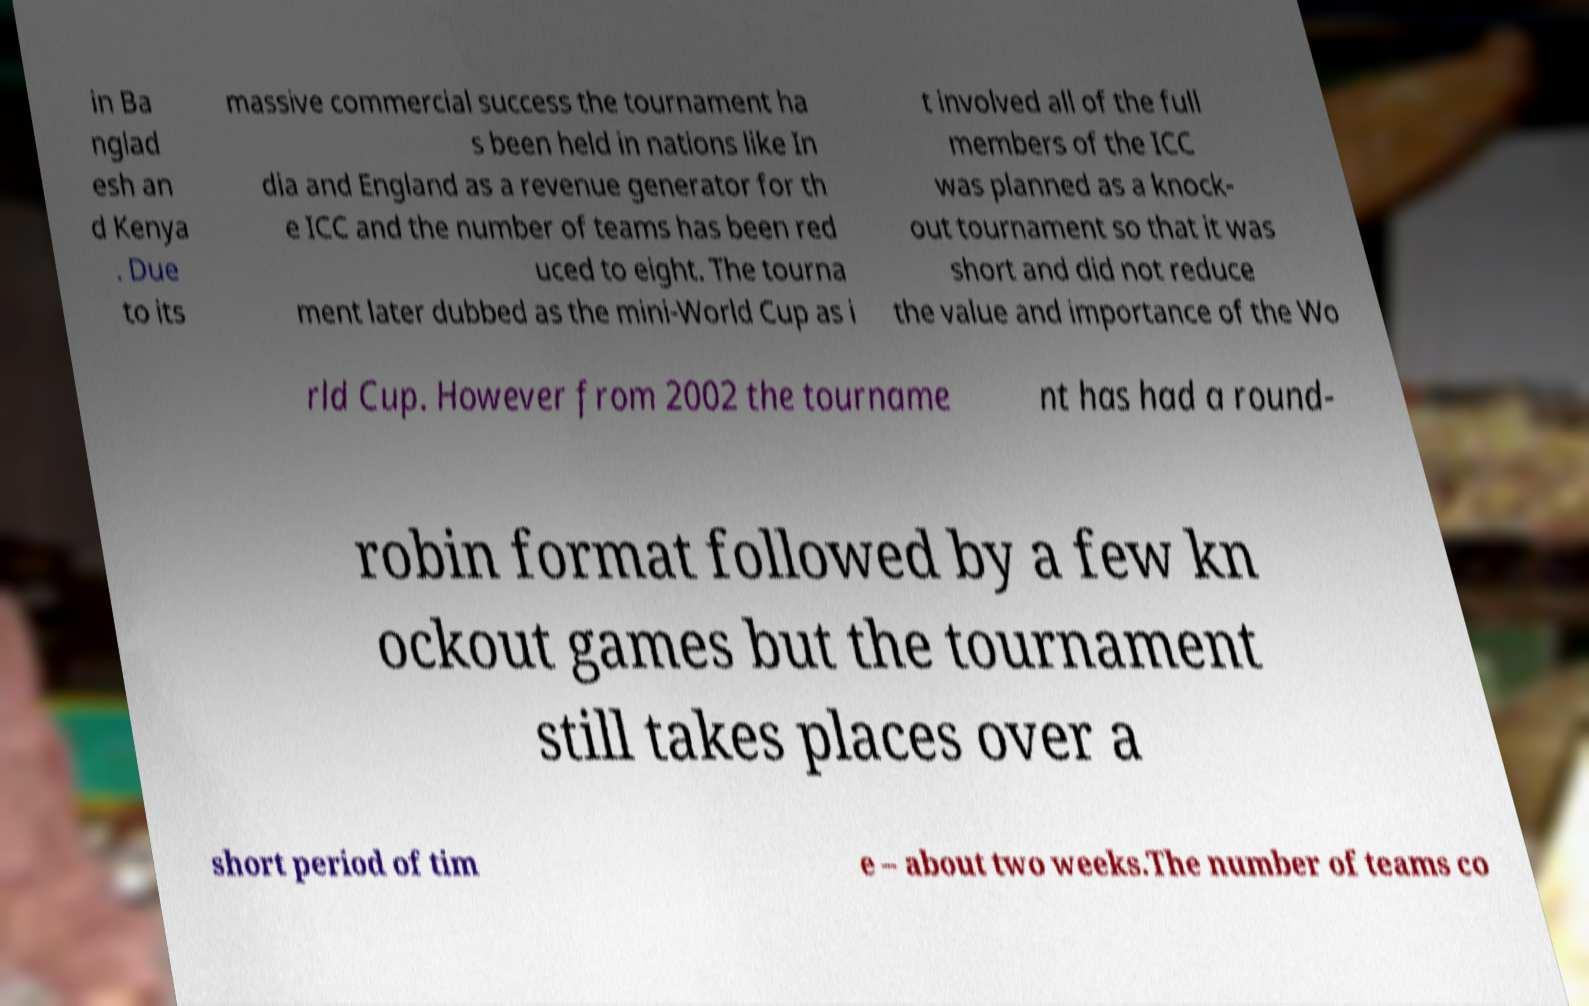Please identify and transcribe the text found in this image. in Ba nglad esh an d Kenya . Due to its massive commercial success the tournament ha s been held in nations like In dia and England as a revenue generator for th e ICC and the number of teams has been red uced to eight. The tourna ment later dubbed as the mini-World Cup as i t involved all of the full members of the ICC was planned as a knock- out tournament so that it was short and did not reduce the value and importance of the Wo rld Cup. However from 2002 the tourname nt has had a round- robin format followed by a few kn ockout games but the tournament still takes places over a short period of tim e – about two weeks.The number of teams co 